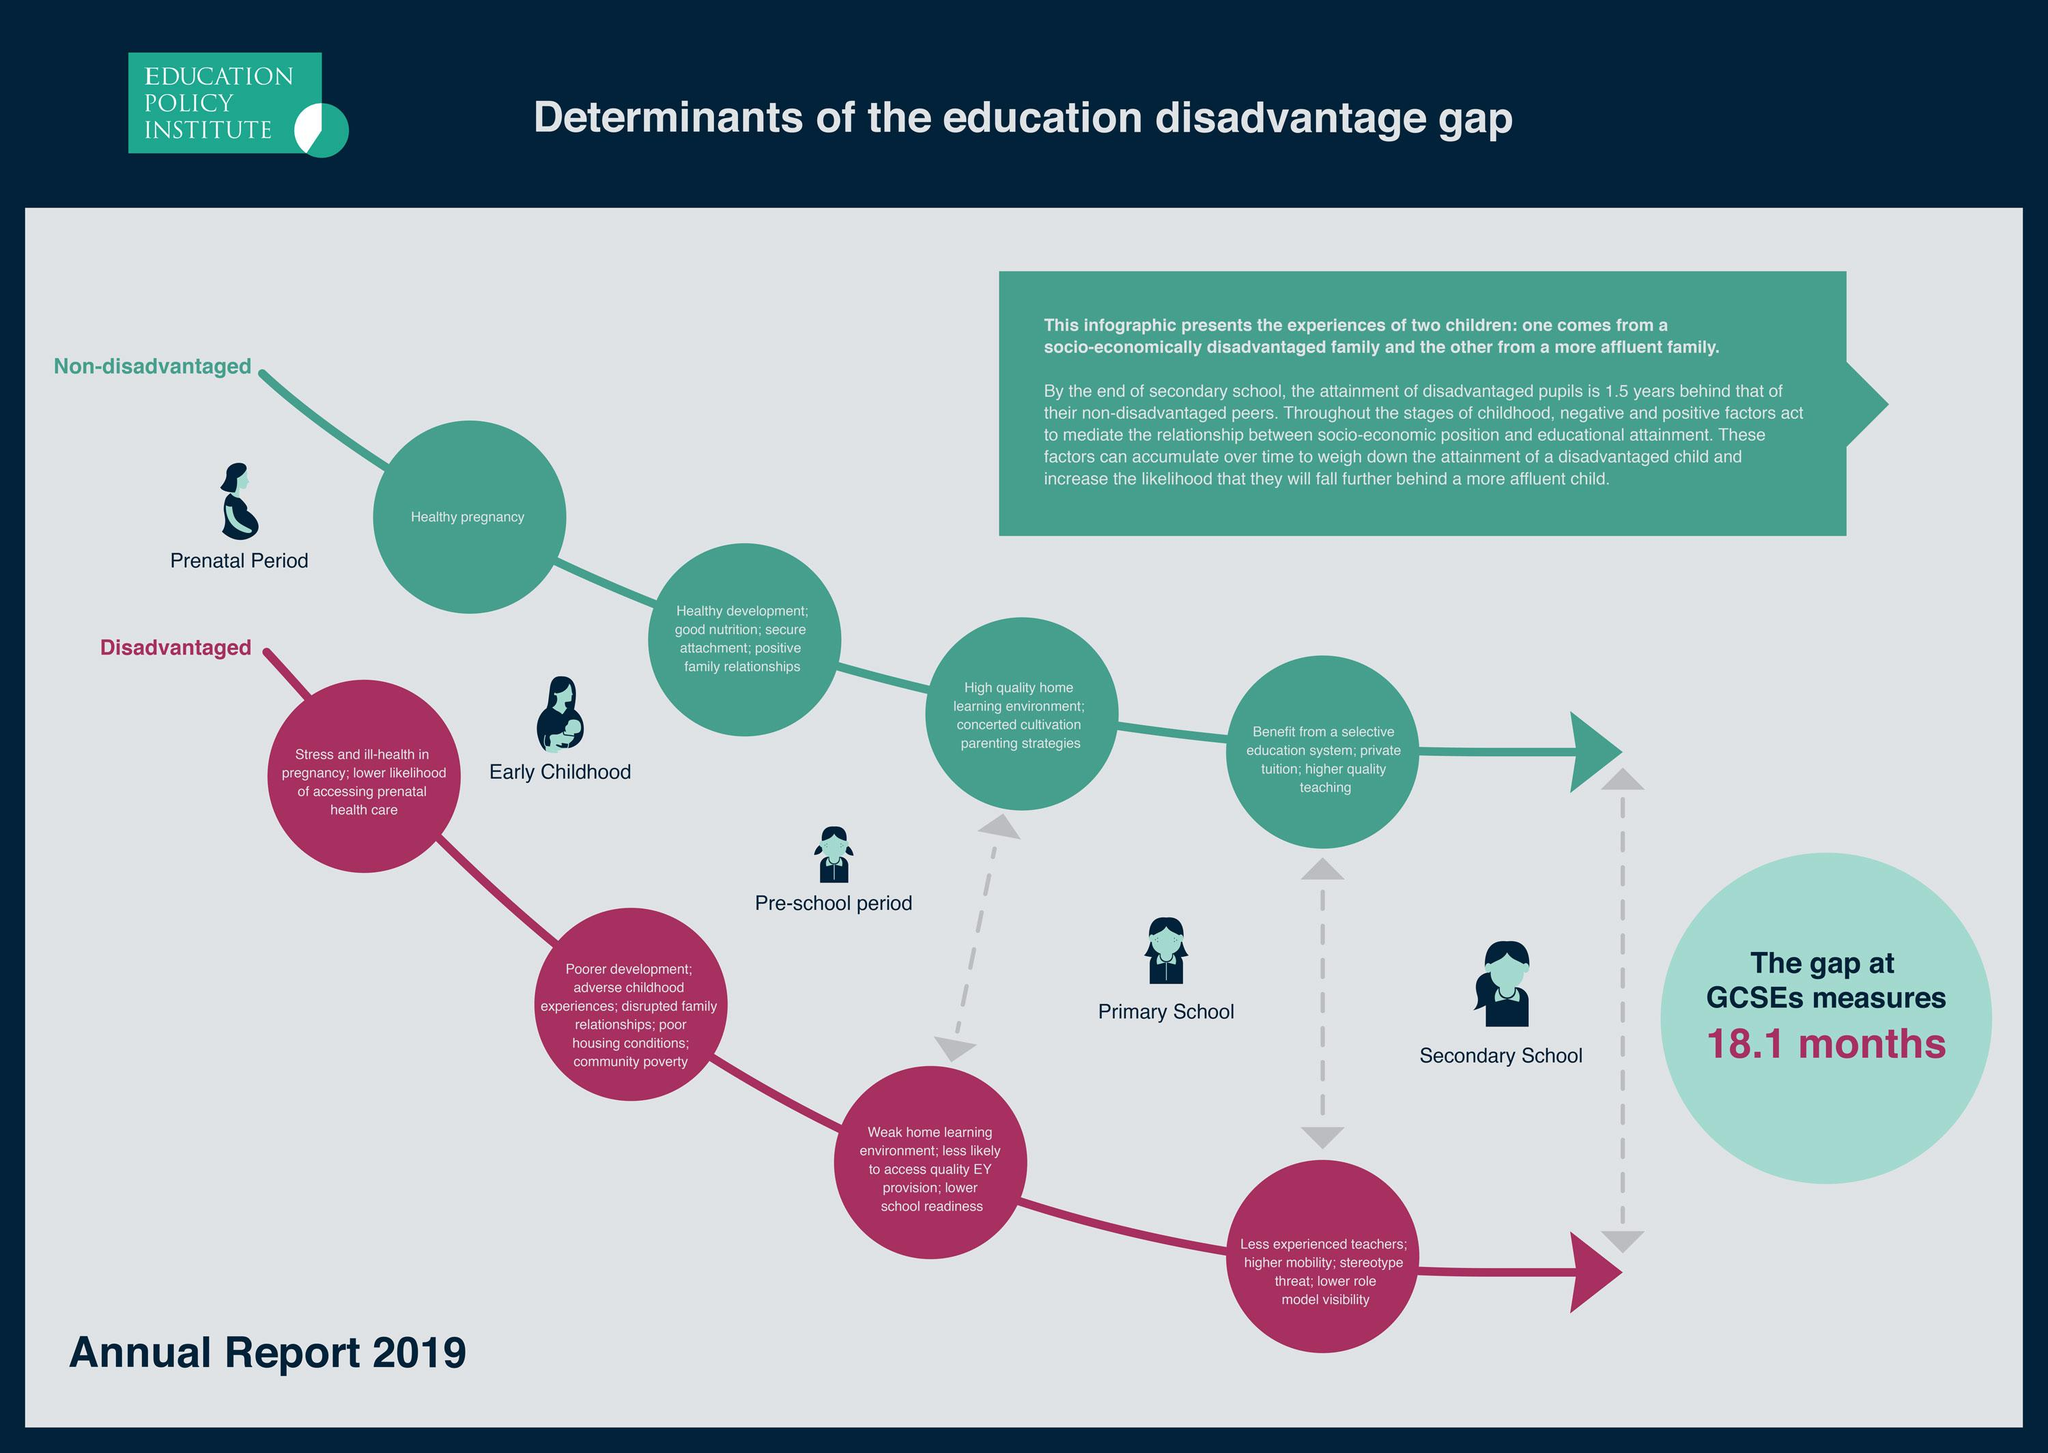Highlight a few significant elements in this photo. A non-disadvantaged child typically has access to a high-quality learning environment during the pre-school period, which promotes their cognitive, social, emotional, and physical development. According to research, disadvantaged children often have a weak home learning environment during the pre-school period, which can have a negative impact on their cognitive and socio-emotional development. The child who received good nutrition in early childhood was non-disadvantaged. Disadvantaged families often experience disrupted relationships, characterized by a lack of stability and consistency in various forms of communication and support. Which child receives lower visibility as a role model? The disadvantaged child. 